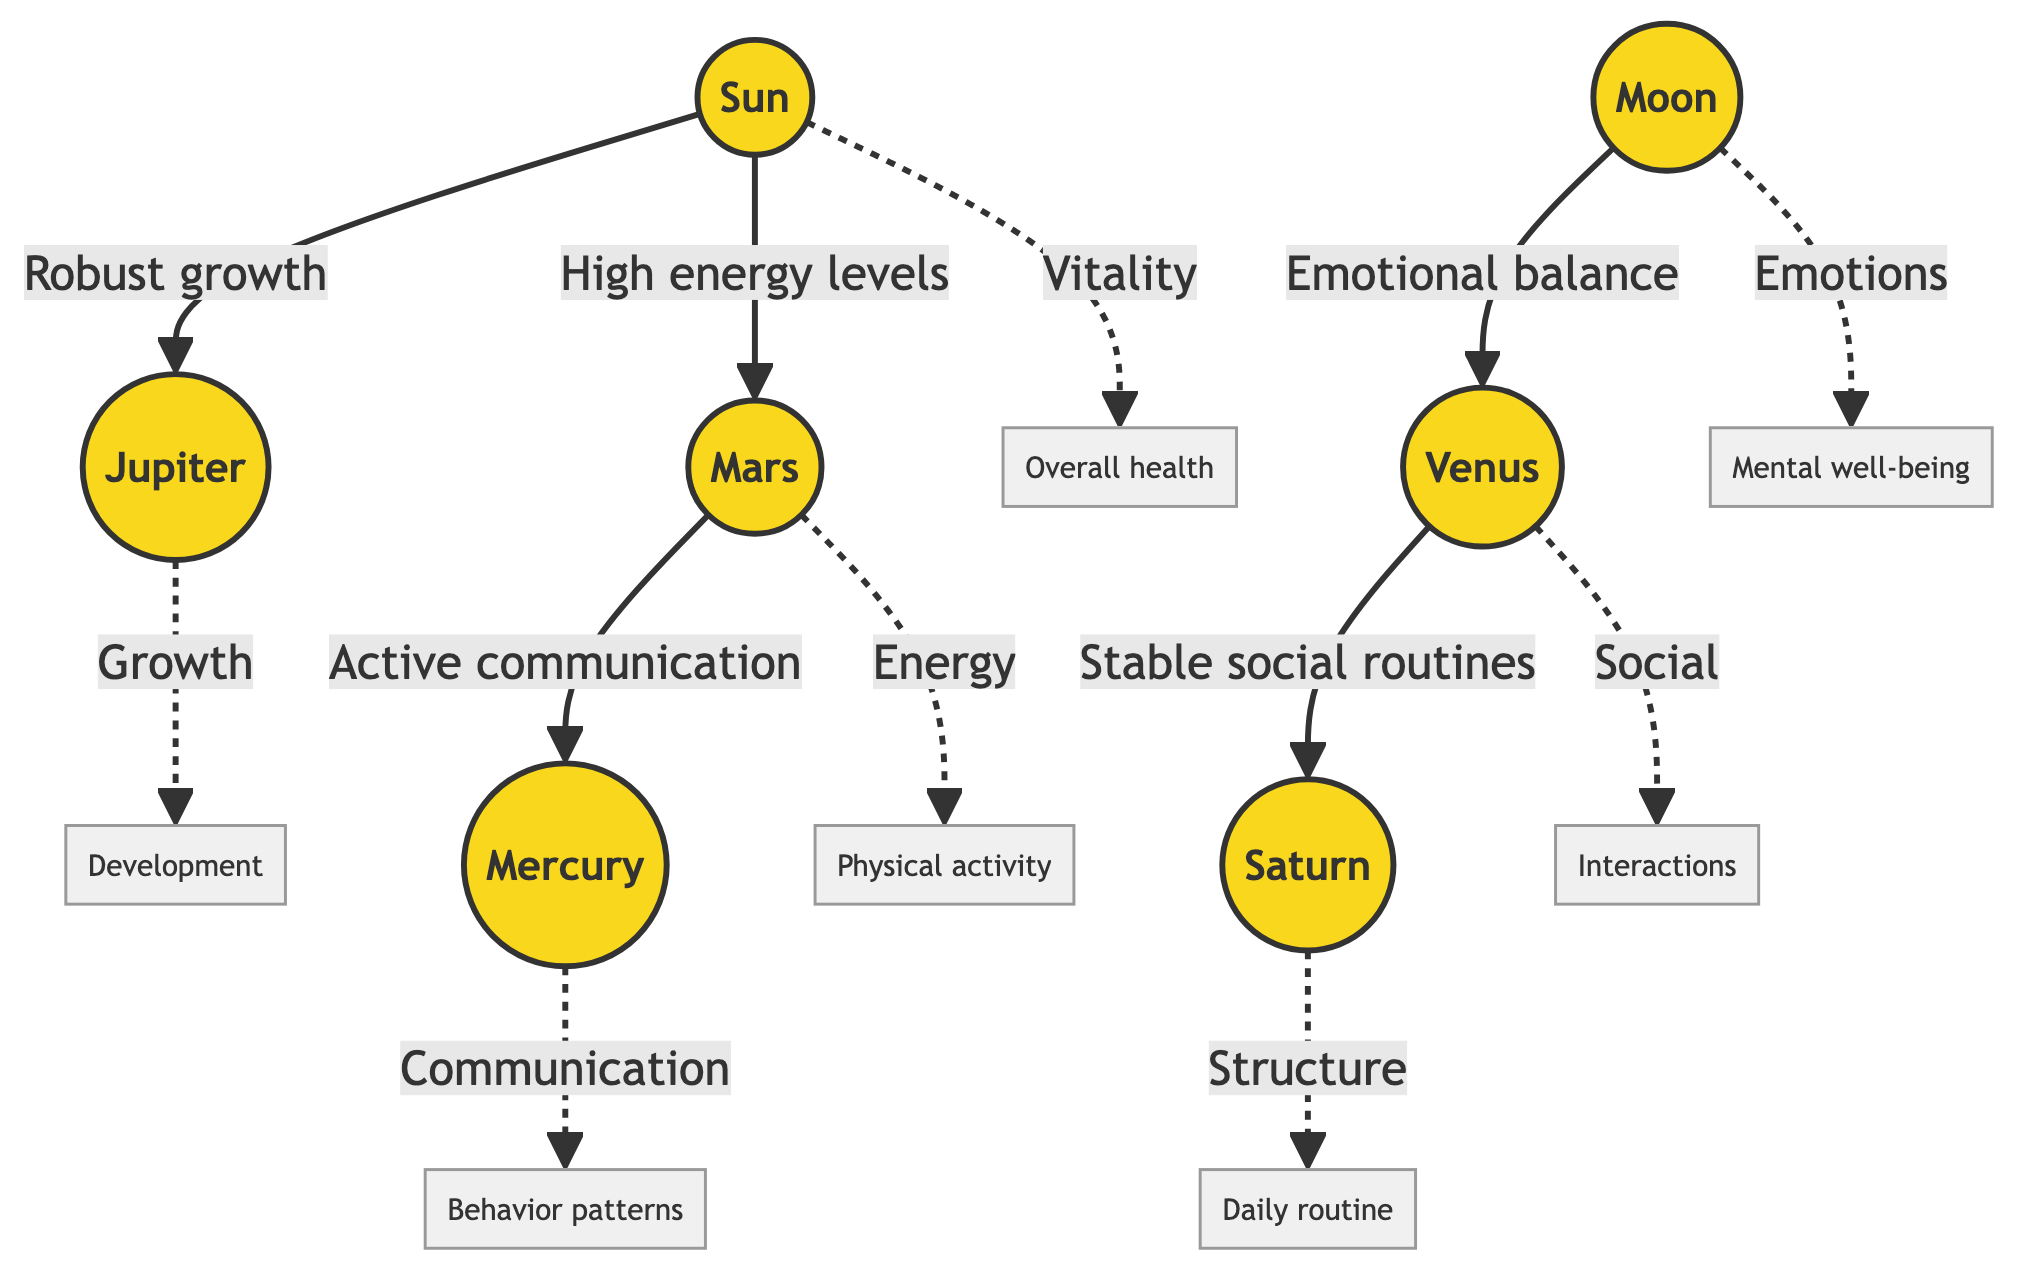What is the role associated with Jupiter in the diagram? The diagram indicates that Jupiter is associated with "Robust growth" which connects it to the Sun. It highlights Jupiter's contribution to overall development.
Answer: Robust growth Which planet is connected to emotional balance? The Moon is connected to emotional balance and this relationship leads to Venus, signifying how lunar influences aid emotional aspects in holistic pet health.
Answer: Moon How many planets are present in the diagram? The diagram presents a total of seven distinct planets, which are Sun, Moon, Mars, Jupiter, Venus, Mercury, and Saturn, thus focusing on diverse planetary influences.
Answer: Seven What does the connection between Sun and Mars signify? The connection between the Sun and Mars signifies "High energy levels," indicating that solar influence helps boost physical energy, essential for pet vitality.
Answer: High energy levels Which planetary alignment is associated with daily routines? Saturn is associated with "Structure," indicating its role in maintaining stable daily routines for holistic pet care practices as depicted in the alignment.
Answer: Structure Which planet has a direct relationship with both Venus and Saturn? Venus has a direct relationship with both the Moon (through emotional balance) and Saturn (through stable social routines), indicating its centrality in social dynamics.
Answer: Venus What is the implication of the link from Mars to Mercury? The link from Mars to Mercury indicates "Active communication," highlighting the importance of energetic interactions in understanding pet behavior patterns.
Answer: Active communication What is suggested by the phrase connected to Jupiter? The phrase connected to Jupiter is "Growth," showcasing its influence on the development of pets when considering holistic health practices aligned with celestial positions.
Answer: Growth What emotion is represented by the Moon in the diagram? The Moon represents the emotion aspect of "Emotions," which is visually suggested in the alignment relating to pet mental well-being and holistic approaches.
Answer: Emotions 